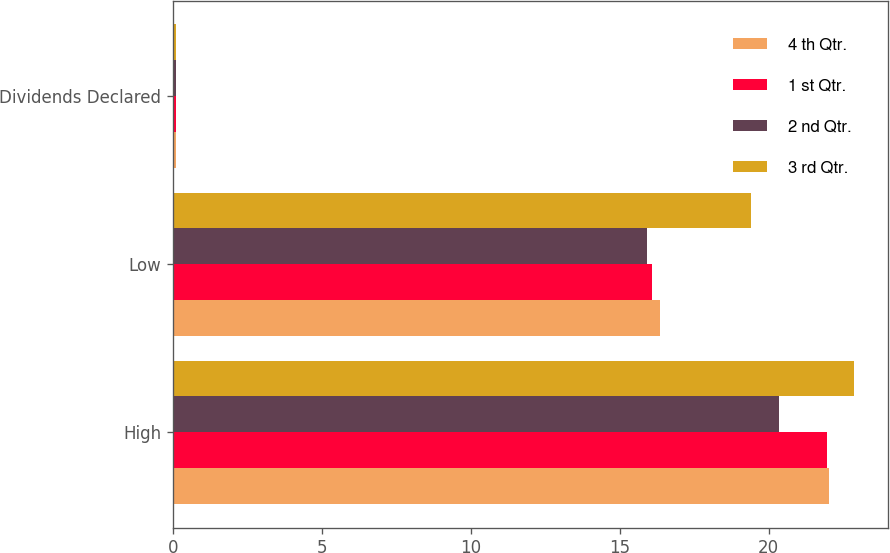<chart> <loc_0><loc_0><loc_500><loc_500><stacked_bar_chart><ecel><fcel>High<fcel>Low<fcel>Dividends Declared<nl><fcel>4 th Qtr.<fcel>22.02<fcel>16.37<fcel>0.1<nl><fcel>1 st Qtr.<fcel>21.95<fcel>16.1<fcel>0.1<nl><fcel>2 nd Qtr.<fcel>20.34<fcel>15.93<fcel>0.1<nl><fcel>3 rd Qtr.<fcel>22.88<fcel>19.41<fcel>0.1<nl></chart> 